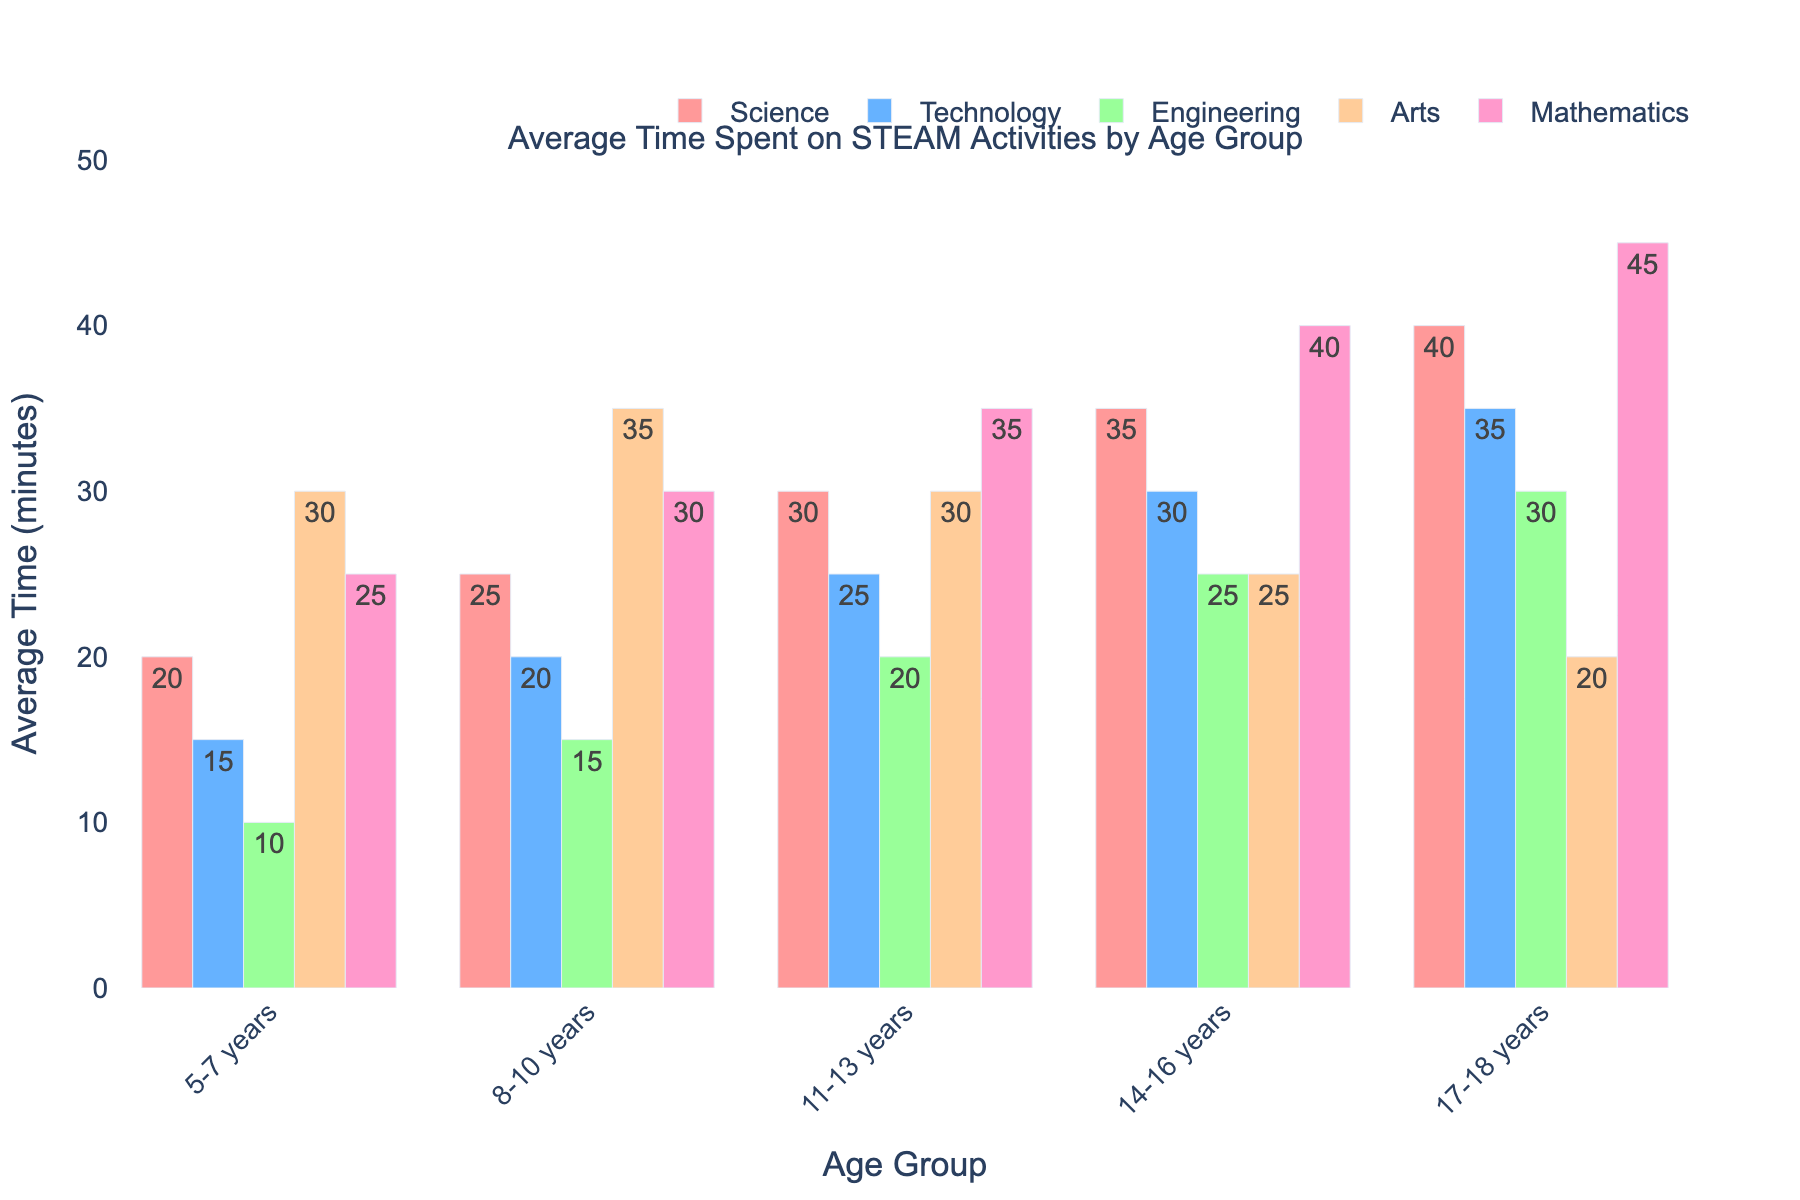Which age group spends the most time on Science activities? By looking at the height of the bars for Science across all age groups, the age group 17-18 years has the tallest bar, indicating the highest time spent.
Answer: 17-18 years How much more time do 14-16 years olds spend on Mathematics compared to Arts? From the figure, find the bars for Mathematics and Arts for the 14-16 years group. Subtract the height of the Arts bar (25) from the height of the Mathematics bar (40). The difference is 40 - 25 = 15 minutes.
Answer: 15 minutes What is the average time spent on Engineering activities across all age groups? Sum the heights of the Engineering bars for all age groups (10 + 15 + 20 + 25 + 30 = 100) and then divide by the number of age groups (5). 100 / 5 = 20.
Answer: 20 minutes Which STEAM activity sees the least increase in time spent from the 5-7 years age group to the 17-18 years age group? Compare the differences between the heights of the bars for each activity from the 5-7 years group to the 17-18 years group. The smallest increase is in Arts (30 - 20 = 10).
Answer: Arts What is the total time spent on Arts activities by 8-10 and 14-16 years age groups combined? Add the heights of the Arts bars for the 8-10 (35) and 14-16 (25) years groups. The total is 35 + 25 = 60 minutes.
Answer: 60 minutes Do any age groups spend equal time on both Science and Mathematics? Observe the bars for Science and Mathematics for each age group and compare their heights. No age groups have bars of equal height for these activities.
Answer: No Which activity has the most consistent increase in time spent as age increases? Look at the heights of the bars for each activity across all age groups. Science increases steadily (20 to 40), while other activities have more variable increases.
Answer: Science 